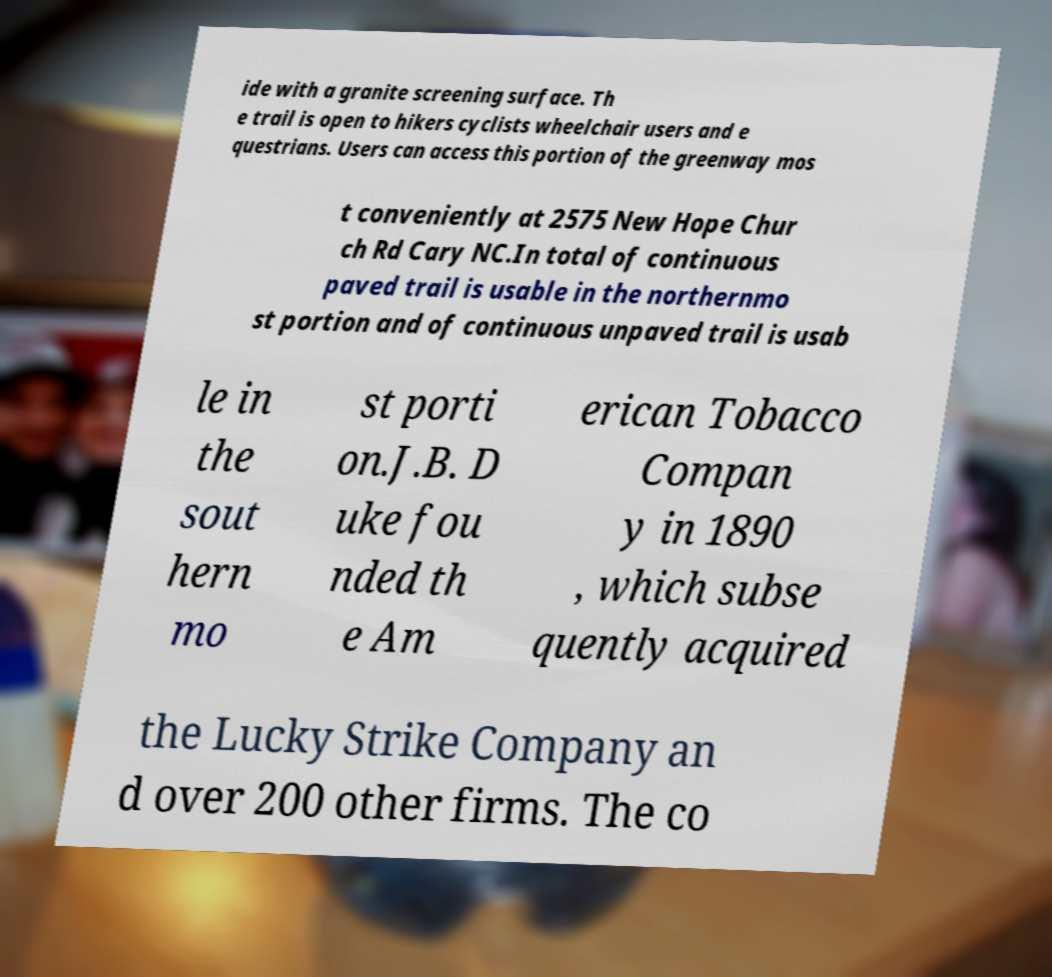Please read and relay the text visible in this image. What does it say? ide with a granite screening surface. Th e trail is open to hikers cyclists wheelchair users and e questrians. Users can access this portion of the greenway mos t conveniently at 2575 New Hope Chur ch Rd Cary NC.In total of continuous paved trail is usable in the northernmo st portion and of continuous unpaved trail is usab le in the sout hern mo st porti on.J.B. D uke fou nded th e Am erican Tobacco Compan y in 1890 , which subse quently acquired the Lucky Strike Company an d over 200 other firms. The co 